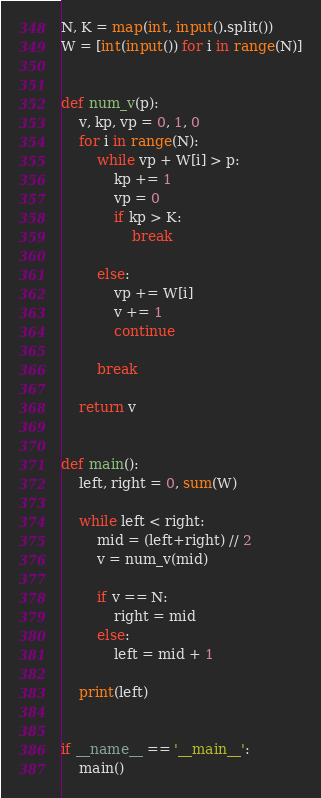<code> <loc_0><loc_0><loc_500><loc_500><_Python_>N, K = map(int, input().split())
W = [int(input()) for i in range(N)]


def num_v(p):
    v, kp, vp = 0, 1, 0
    for i in range(N):
        while vp + W[i] > p:
            kp += 1
            vp = 0
            if kp > K:
                break

        else:
            vp += W[i]
            v += 1
            continue

        break

    return v


def main():
    left, right = 0, sum(W)

    while left < right:
        mid = (left+right) // 2
        v = num_v(mid)

        if v == N:
            right = mid
        else:
            left = mid + 1

    print(left)


if __name__ == '__main__':
    main()

</code> 